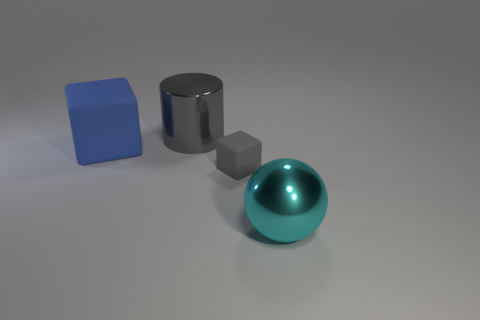Add 3 tiny cyan things. How many objects exist? 7 Subtract all gray cubes. How many cubes are left? 1 Subtract all cylinders. How many objects are left? 3 Subtract 1 cyan spheres. How many objects are left? 3 Subtract all red spheres. Subtract all green cylinders. How many spheres are left? 1 Subtract all cyan matte cylinders. Subtract all big rubber objects. How many objects are left? 3 Add 3 metal spheres. How many metal spheres are left? 4 Add 2 small blue matte spheres. How many small blue matte spheres exist? 2 